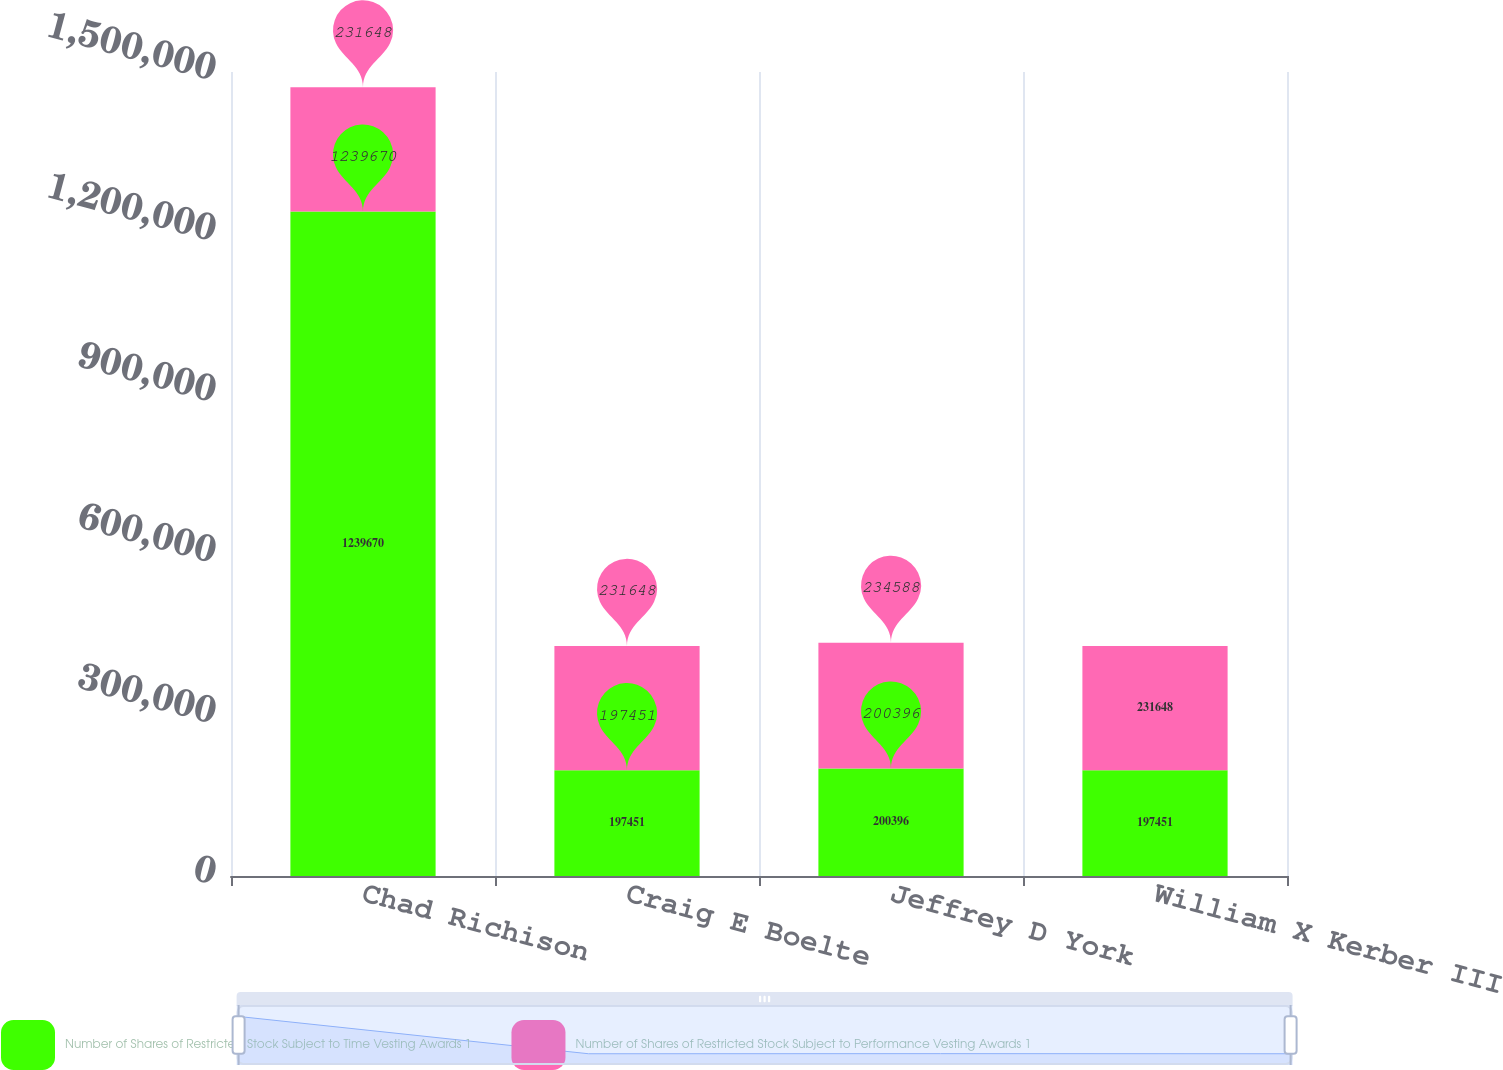<chart> <loc_0><loc_0><loc_500><loc_500><stacked_bar_chart><ecel><fcel>Chad Richison<fcel>Craig E Boelte<fcel>Jeffrey D York<fcel>William X Kerber III<nl><fcel>Number of Shares of Restricted Stock Subject to Time Vesting Awards 1<fcel>1.23967e+06<fcel>197451<fcel>200396<fcel>197451<nl><fcel>Number of Shares of Restricted Stock Subject to Performance Vesting Awards 1<fcel>231648<fcel>231648<fcel>234588<fcel>231648<nl></chart> 